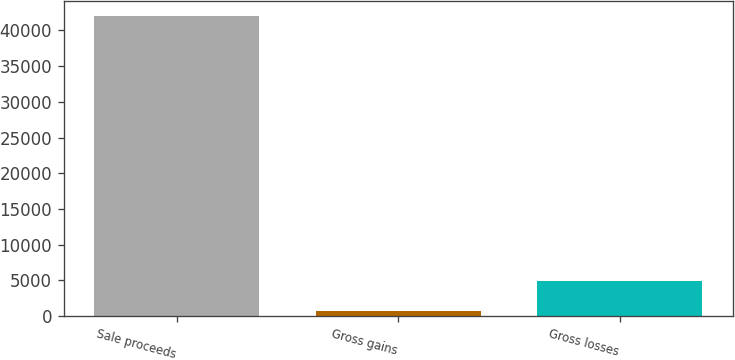Convert chart. <chart><loc_0><loc_0><loc_500><loc_500><bar_chart><fcel>Sale proceeds<fcel>Gross gains<fcel>Gross losses<nl><fcel>41973<fcel>755<fcel>4876.8<nl></chart> 